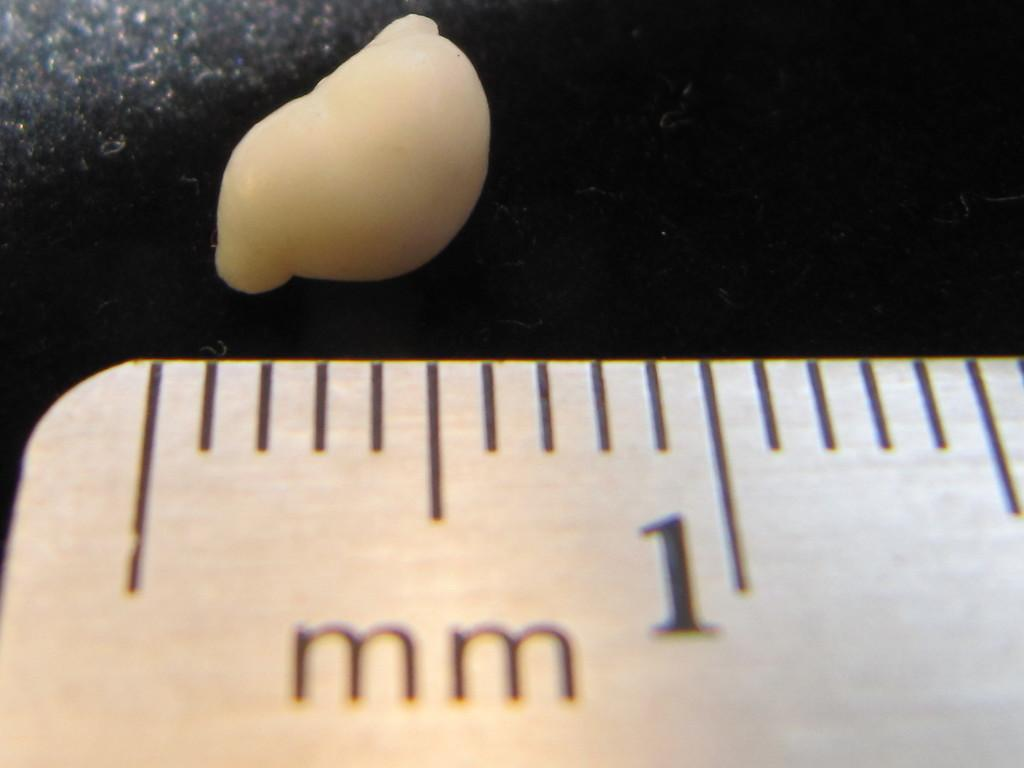<image>
Give a short and clear explanation of the subsequent image. A ruler has the measurement for 1 mm. 